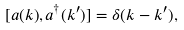Convert formula to latex. <formula><loc_0><loc_0><loc_500><loc_500>[ a ( { k } ) , a ^ { \dagger } ( { k } ^ { \prime } ) ] = \delta ( { k } - { k } ^ { \prime } ) ,</formula> 